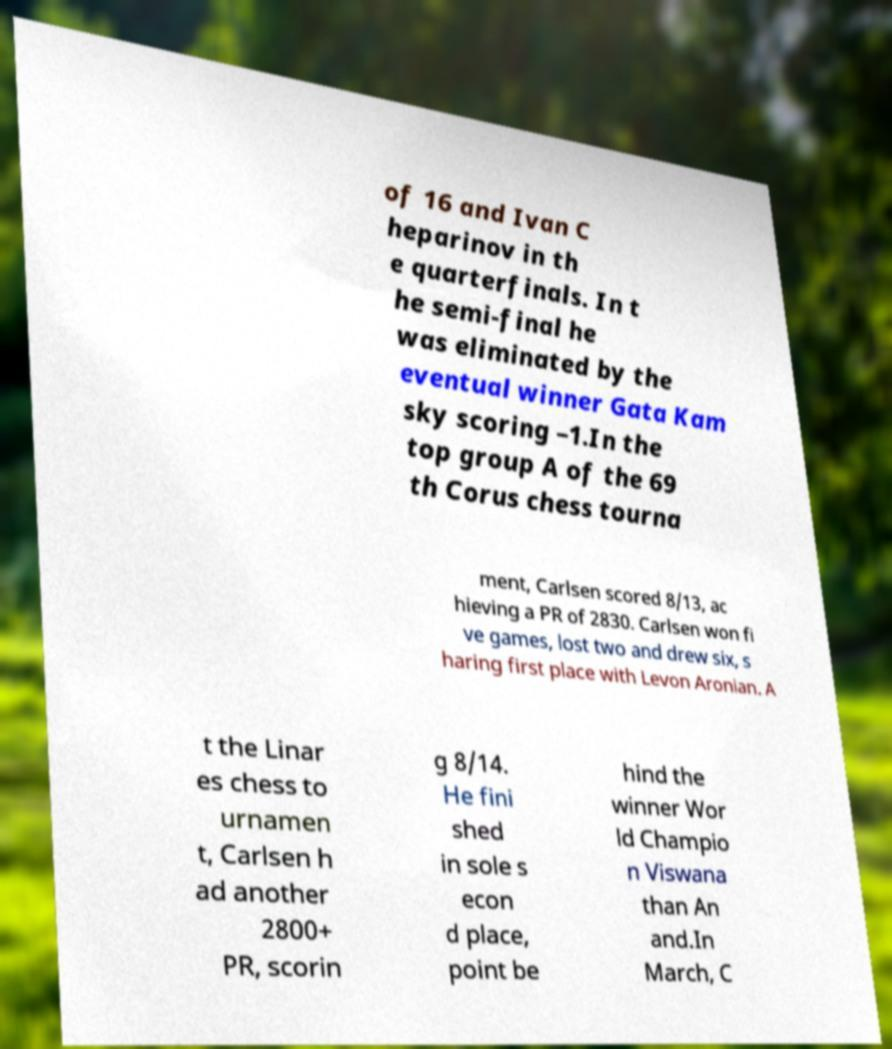Can you accurately transcribe the text from the provided image for me? of 16 and Ivan C heparinov in th e quarterfinals. In t he semi-final he was eliminated by the eventual winner Gata Kam sky scoring –1.In the top group A of the 69 th Corus chess tourna ment, Carlsen scored 8/13, ac hieving a PR of 2830. Carlsen won fi ve games, lost two and drew six, s haring first place with Levon Aronian. A t the Linar es chess to urnamen t, Carlsen h ad another 2800+ PR, scorin g 8/14. He fini shed in sole s econ d place, point be hind the winner Wor ld Champio n Viswana than An and.In March, C 